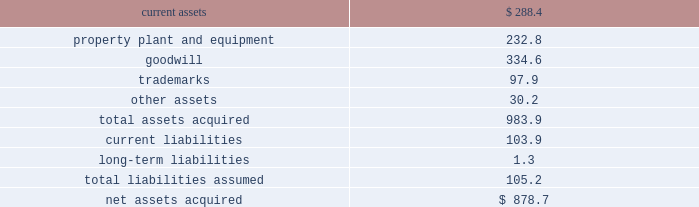492010 annual report consolidation 2013 effective february 28 , 2010 , the company adopted the fasb amended guidance for con- solidation .
This guidance clarifies that the scope of the decrease in ownership provisions applies to the follow- ing : ( i ) a subsidiary or group of assets that is a business or nonprofit activity ; ( ii ) a subsidiary that is a business or nonprofit activity that is transferred to an equity method investee or joint venture ; and ( iii ) an exchange of a group of assets that constitutes a business or nonprofit activ- ity for a noncontrolling interest in an entity ( including an equity method investee or joint venture ) .
This guidance also expands the disclosures about the deconsolidation of a subsidiary or derecognition of a group of assets within the scope of the guidance .
The adoption of this guidance did not have a material impact on the company 2019s consolidated financial statements .
3 . acquisitions : acquisition of bwe 2013 on december 17 , 2007 , the company acquired all of the issued and outstanding capital stock of beam wine estates , inc .
( 201cbwe 201d ) , an indirect wholly-owned subsidiary of fortune brands , inc. , together with bwe 2019s subsidiaries : atlas peak vineyards , inc. , buena vista winery , inc. , clos du bois , inc. , gary farrell wines , inc .
And peak wines international , inc .
( the 201cbwe acquisition 201d ) .
As a result of the bwe acquisition , the company acquired the u.s .
Wine portfolio of fortune brands , inc. , including certain wineries , vineyards or inter- ests therein in the state of california , as well as various super-premium and fine california wine brands including clos du bois and wild horse .
The bwe acquisition sup- ports the company 2019s strategy of strengthening its portfolio with fast-growing super-premium and above wines .
The bwe acquisition strengthens the company 2019s position as the leading wine company in the world and the leading premium wine company in the u.s .
Total consideration paid in cash was $ 877.3 million .
In addition , the company incurred direct acquisition costs of $ 1.4 million .
The purchase price was financed with the net proceeds from the company 2019s december 2007 senior notes ( as defined in note 11 ) and revolver borrowings under the company 2019s june 2006 credit agreement , as amended in february 2007 and november 2007 ( as defined in note 11 ) .
In accordance with the purchase method of accounting , the acquired net assets are recorded at fair value at the date of acquisition .
The purchase price was based primarily on the estimated future operating results of the bwe business , including the factors described above .
In june 2008 , the company sold certain businesses consisting of several of the california wineries and wine brands acquired in the bwe acquisition , as well as certain wineries and wine brands from the states of washington and idaho ( collectively , the 201cpacific northwest business 201d ) ( see note 7 ) .
The results of operations of the bwe business are reported in the constellation wines segment and are included in the consolidated results of operations of the company from the date of acquisition .
The table summarizes the fair values of the assets acquired and liabilities assumed in the bwe acquisition at the date of acquisition .
( in millions ) current assets $ 288.4 property , plant and equipment 232.8 .
Other assets 30.2 total assets acquired 983.9 current liabilities 103.9 long-term liabilities 1.3 total liabilities assumed 105.2 net assets acquired $ 878.7 the trademarks are not subject to amortization .
All of the goodwill is expected to be deductible for tax purposes .
Acquisition of svedka 2013 on march 19 , 2007 , the company acquired the svedka vodka brand ( 201csvedka 201d ) in connection with the acquisition of spirits marque one llc and related business ( the 201csvedka acquisition 201d ) .
Svedka is a premium swedish vodka .
At the time of the acquisition , the svedka acquisition supported the company 2019s strategy of expanding the company 2019s premium spirits business and provided a foundation from which the company looked to leverage its existing and future premium spirits portfolio for growth .
In addition , svedka complemented the company 2019s then existing portfolio of super-premium and value vodka brands by adding a premium vodka brand .
Total consideration paid in cash for the svedka acquisition was $ 385.8 million .
In addition , the company incurred direct acquisition costs of $ 1.3 million .
The pur- chase price was financed with revolver borrowings under the company 2019s june 2006 credit agreement , as amended in february 2007 .
In accordance with the purchase method of accounting , the acquired net assets are recorded at fair value at the date of acquisition .
The purchase price was based primarily on the estimated future operating results of the svedka business , including the factors described above .
The results of operations of the svedka business are reported in the constellation wines segment and are included in the consolidated results of operations of the company from the date of acquisition. .
What is the working capital of bwe at the time of the acquisition? 
Computations: (288.4 - 103.9)
Answer: 184.5. 